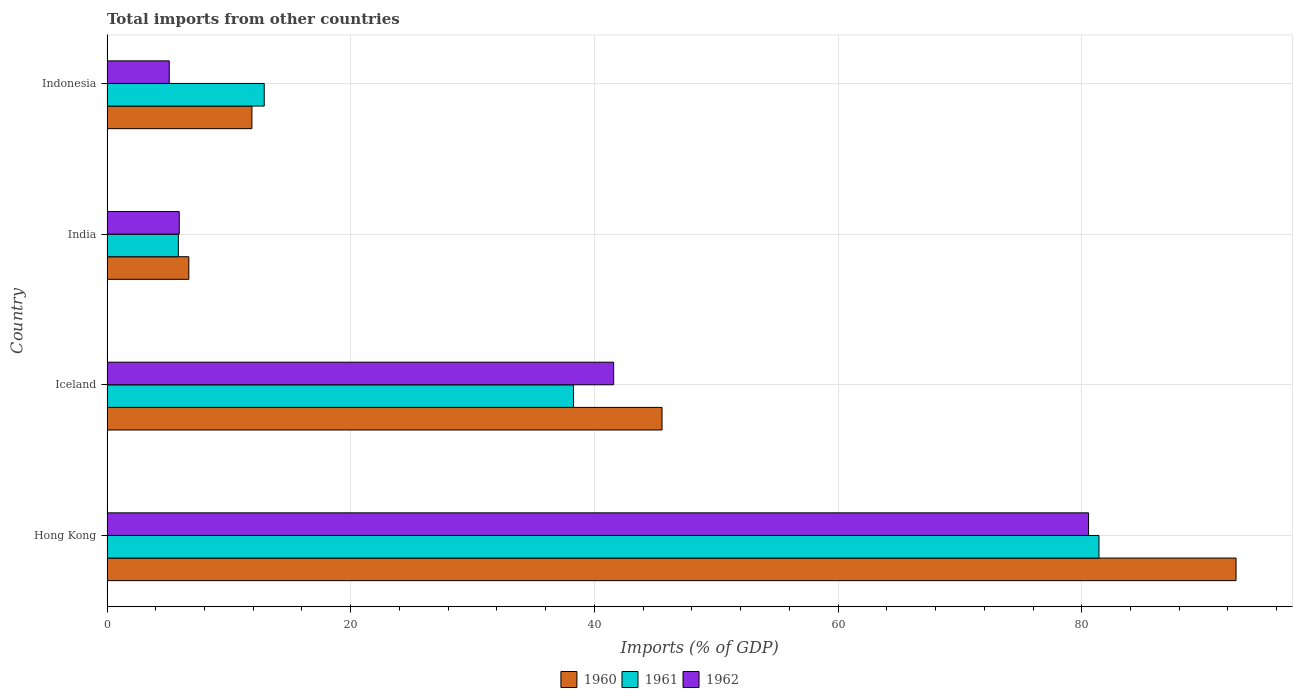How many different coloured bars are there?
Keep it short and to the point. 3. Are the number of bars per tick equal to the number of legend labels?
Your answer should be compact. Yes. Are the number of bars on each tick of the Y-axis equal?
Your response must be concise. Yes. How many bars are there on the 3rd tick from the top?
Ensure brevity in your answer.  3. In how many cases, is the number of bars for a given country not equal to the number of legend labels?
Your answer should be compact. 0. What is the total imports in 1962 in Iceland?
Your answer should be compact. 41.58. Across all countries, what is the maximum total imports in 1962?
Ensure brevity in your answer.  80.56. Across all countries, what is the minimum total imports in 1960?
Your response must be concise. 6.72. In which country was the total imports in 1962 maximum?
Your response must be concise. Hong Kong. What is the total total imports in 1962 in the graph?
Your answer should be very brief. 133.18. What is the difference between the total imports in 1962 in Iceland and that in India?
Give a very brief answer. 35.66. What is the difference between the total imports in 1961 in India and the total imports in 1960 in Indonesia?
Make the answer very short. -6.04. What is the average total imports in 1961 per country?
Give a very brief answer. 34.61. What is the difference between the total imports in 1962 and total imports in 1960 in Iceland?
Ensure brevity in your answer.  -3.97. In how many countries, is the total imports in 1961 greater than 60 %?
Make the answer very short. 1. What is the ratio of the total imports in 1962 in India to that in Indonesia?
Your answer should be compact. 1.16. What is the difference between the highest and the second highest total imports in 1961?
Provide a succinct answer. 43.13. What is the difference between the highest and the lowest total imports in 1962?
Provide a succinct answer. 75.45. In how many countries, is the total imports in 1960 greater than the average total imports in 1960 taken over all countries?
Offer a very short reply. 2. Is the sum of the total imports in 1962 in Hong Kong and Iceland greater than the maximum total imports in 1960 across all countries?
Your answer should be very brief. Yes. What does the 3rd bar from the top in India represents?
Your response must be concise. 1960. Is it the case that in every country, the sum of the total imports in 1962 and total imports in 1961 is greater than the total imports in 1960?
Your answer should be very brief. Yes. How many bars are there?
Offer a very short reply. 12. Are all the bars in the graph horizontal?
Your answer should be compact. Yes. Are the values on the major ticks of X-axis written in scientific E-notation?
Ensure brevity in your answer.  No. Where does the legend appear in the graph?
Provide a succinct answer. Bottom center. How many legend labels are there?
Your answer should be very brief. 3. What is the title of the graph?
Keep it short and to the point. Total imports from other countries. Does "1983" appear as one of the legend labels in the graph?
Offer a very short reply. No. What is the label or title of the X-axis?
Provide a short and direct response. Imports (% of GDP). What is the Imports (% of GDP) in 1960 in Hong Kong?
Provide a succinct answer. 92.66. What is the Imports (% of GDP) in 1961 in Hong Kong?
Your response must be concise. 81.41. What is the Imports (% of GDP) of 1962 in Hong Kong?
Give a very brief answer. 80.56. What is the Imports (% of GDP) in 1960 in Iceland?
Ensure brevity in your answer.  45.55. What is the Imports (% of GDP) in 1961 in Iceland?
Provide a succinct answer. 38.28. What is the Imports (% of GDP) of 1962 in Iceland?
Provide a succinct answer. 41.58. What is the Imports (% of GDP) in 1960 in India?
Provide a succinct answer. 6.72. What is the Imports (% of GDP) of 1961 in India?
Your response must be concise. 5.85. What is the Imports (% of GDP) in 1962 in India?
Your answer should be very brief. 5.93. What is the Imports (% of GDP) of 1960 in Indonesia?
Make the answer very short. 11.89. What is the Imports (% of GDP) of 1961 in Indonesia?
Give a very brief answer. 12.9. What is the Imports (% of GDP) of 1962 in Indonesia?
Offer a very short reply. 5.11. Across all countries, what is the maximum Imports (% of GDP) of 1960?
Your answer should be compact. 92.66. Across all countries, what is the maximum Imports (% of GDP) in 1961?
Provide a short and direct response. 81.41. Across all countries, what is the maximum Imports (% of GDP) in 1962?
Provide a succinct answer. 80.56. Across all countries, what is the minimum Imports (% of GDP) of 1960?
Give a very brief answer. 6.72. Across all countries, what is the minimum Imports (% of GDP) in 1961?
Keep it short and to the point. 5.85. Across all countries, what is the minimum Imports (% of GDP) in 1962?
Offer a very short reply. 5.11. What is the total Imports (% of GDP) of 1960 in the graph?
Ensure brevity in your answer.  156.83. What is the total Imports (% of GDP) of 1961 in the graph?
Give a very brief answer. 138.45. What is the total Imports (% of GDP) of 1962 in the graph?
Your answer should be compact. 133.18. What is the difference between the Imports (% of GDP) of 1960 in Hong Kong and that in Iceland?
Your answer should be very brief. 47.11. What is the difference between the Imports (% of GDP) in 1961 in Hong Kong and that in Iceland?
Provide a succinct answer. 43.13. What is the difference between the Imports (% of GDP) in 1962 in Hong Kong and that in Iceland?
Keep it short and to the point. 38.97. What is the difference between the Imports (% of GDP) of 1960 in Hong Kong and that in India?
Keep it short and to the point. 85.95. What is the difference between the Imports (% of GDP) in 1961 in Hong Kong and that in India?
Make the answer very short. 75.56. What is the difference between the Imports (% of GDP) of 1962 in Hong Kong and that in India?
Give a very brief answer. 74.63. What is the difference between the Imports (% of GDP) in 1960 in Hong Kong and that in Indonesia?
Your response must be concise. 80.77. What is the difference between the Imports (% of GDP) in 1961 in Hong Kong and that in Indonesia?
Your answer should be very brief. 68.51. What is the difference between the Imports (% of GDP) of 1962 in Hong Kong and that in Indonesia?
Ensure brevity in your answer.  75.45. What is the difference between the Imports (% of GDP) of 1960 in Iceland and that in India?
Keep it short and to the point. 38.84. What is the difference between the Imports (% of GDP) of 1961 in Iceland and that in India?
Offer a very short reply. 32.43. What is the difference between the Imports (% of GDP) of 1962 in Iceland and that in India?
Keep it short and to the point. 35.66. What is the difference between the Imports (% of GDP) in 1960 in Iceland and that in Indonesia?
Your answer should be very brief. 33.66. What is the difference between the Imports (% of GDP) in 1961 in Iceland and that in Indonesia?
Provide a short and direct response. 25.38. What is the difference between the Imports (% of GDP) of 1962 in Iceland and that in Indonesia?
Your response must be concise. 36.47. What is the difference between the Imports (% of GDP) in 1960 in India and that in Indonesia?
Keep it short and to the point. -5.18. What is the difference between the Imports (% of GDP) of 1961 in India and that in Indonesia?
Your answer should be very brief. -7.05. What is the difference between the Imports (% of GDP) in 1962 in India and that in Indonesia?
Your answer should be compact. 0.82. What is the difference between the Imports (% of GDP) of 1960 in Hong Kong and the Imports (% of GDP) of 1961 in Iceland?
Your response must be concise. 54.38. What is the difference between the Imports (% of GDP) of 1960 in Hong Kong and the Imports (% of GDP) of 1962 in Iceland?
Your answer should be very brief. 51.08. What is the difference between the Imports (% of GDP) of 1961 in Hong Kong and the Imports (% of GDP) of 1962 in Iceland?
Give a very brief answer. 39.83. What is the difference between the Imports (% of GDP) in 1960 in Hong Kong and the Imports (% of GDP) in 1961 in India?
Provide a short and direct response. 86.81. What is the difference between the Imports (% of GDP) in 1960 in Hong Kong and the Imports (% of GDP) in 1962 in India?
Make the answer very short. 86.74. What is the difference between the Imports (% of GDP) in 1961 in Hong Kong and the Imports (% of GDP) in 1962 in India?
Give a very brief answer. 75.49. What is the difference between the Imports (% of GDP) in 1960 in Hong Kong and the Imports (% of GDP) in 1961 in Indonesia?
Provide a succinct answer. 79.76. What is the difference between the Imports (% of GDP) of 1960 in Hong Kong and the Imports (% of GDP) of 1962 in Indonesia?
Offer a very short reply. 87.55. What is the difference between the Imports (% of GDP) of 1961 in Hong Kong and the Imports (% of GDP) of 1962 in Indonesia?
Make the answer very short. 76.3. What is the difference between the Imports (% of GDP) of 1960 in Iceland and the Imports (% of GDP) of 1961 in India?
Provide a short and direct response. 39.7. What is the difference between the Imports (% of GDP) of 1960 in Iceland and the Imports (% of GDP) of 1962 in India?
Offer a terse response. 39.63. What is the difference between the Imports (% of GDP) of 1961 in Iceland and the Imports (% of GDP) of 1962 in India?
Provide a succinct answer. 32.35. What is the difference between the Imports (% of GDP) in 1960 in Iceland and the Imports (% of GDP) in 1961 in Indonesia?
Your answer should be very brief. 32.65. What is the difference between the Imports (% of GDP) of 1960 in Iceland and the Imports (% of GDP) of 1962 in Indonesia?
Provide a short and direct response. 40.44. What is the difference between the Imports (% of GDP) in 1961 in Iceland and the Imports (% of GDP) in 1962 in Indonesia?
Offer a very short reply. 33.17. What is the difference between the Imports (% of GDP) in 1960 in India and the Imports (% of GDP) in 1961 in Indonesia?
Make the answer very short. -6.19. What is the difference between the Imports (% of GDP) in 1960 in India and the Imports (% of GDP) in 1962 in Indonesia?
Your answer should be very brief. 1.61. What is the difference between the Imports (% of GDP) of 1961 in India and the Imports (% of GDP) of 1962 in Indonesia?
Your response must be concise. 0.74. What is the average Imports (% of GDP) of 1960 per country?
Your answer should be compact. 39.21. What is the average Imports (% of GDP) in 1961 per country?
Offer a terse response. 34.61. What is the average Imports (% of GDP) of 1962 per country?
Offer a terse response. 33.3. What is the difference between the Imports (% of GDP) in 1960 and Imports (% of GDP) in 1961 in Hong Kong?
Give a very brief answer. 11.25. What is the difference between the Imports (% of GDP) in 1960 and Imports (% of GDP) in 1962 in Hong Kong?
Offer a very short reply. 12.1. What is the difference between the Imports (% of GDP) of 1961 and Imports (% of GDP) of 1962 in Hong Kong?
Offer a very short reply. 0.85. What is the difference between the Imports (% of GDP) in 1960 and Imports (% of GDP) in 1961 in Iceland?
Ensure brevity in your answer.  7.27. What is the difference between the Imports (% of GDP) of 1960 and Imports (% of GDP) of 1962 in Iceland?
Offer a terse response. 3.97. What is the difference between the Imports (% of GDP) of 1961 and Imports (% of GDP) of 1962 in Iceland?
Keep it short and to the point. -3.3. What is the difference between the Imports (% of GDP) of 1960 and Imports (% of GDP) of 1961 in India?
Give a very brief answer. 0.86. What is the difference between the Imports (% of GDP) of 1960 and Imports (% of GDP) of 1962 in India?
Your answer should be very brief. 0.79. What is the difference between the Imports (% of GDP) of 1961 and Imports (% of GDP) of 1962 in India?
Provide a short and direct response. -0.07. What is the difference between the Imports (% of GDP) in 1960 and Imports (% of GDP) in 1961 in Indonesia?
Ensure brevity in your answer.  -1.01. What is the difference between the Imports (% of GDP) of 1960 and Imports (% of GDP) of 1962 in Indonesia?
Your answer should be very brief. 6.78. What is the difference between the Imports (% of GDP) of 1961 and Imports (% of GDP) of 1962 in Indonesia?
Your answer should be compact. 7.79. What is the ratio of the Imports (% of GDP) in 1960 in Hong Kong to that in Iceland?
Offer a terse response. 2.03. What is the ratio of the Imports (% of GDP) of 1961 in Hong Kong to that in Iceland?
Provide a succinct answer. 2.13. What is the ratio of the Imports (% of GDP) of 1962 in Hong Kong to that in Iceland?
Make the answer very short. 1.94. What is the ratio of the Imports (% of GDP) in 1960 in Hong Kong to that in India?
Your answer should be very brief. 13.8. What is the ratio of the Imports (% of GDP) in 1961 in Hong Kong to that in India?
Your answer should be very brief. 13.91. What is the ratio of the Imports (% of GDP) in 1962 in Hong Kong to that in India?
Provide a succinct answer. 13.59. What is the ratio of the Imports (% of GDP) in 1960 in Hong Kong to that in Indonesia?
Offer a very short reply. 7.79. What is the ratio of the Imports (% of GDP) of 1961 in Hong Kong to that in Indonesia?
Offer a very short reply. 6.31. What is the ratio of the Imports (% of GDP) in 1962 in Hong Kong to that in Indonesia?
Your response must be concise. 15.76. What is the ratio of the Imports (% of GDP) of 1960 in Iceland to that in India?
Offer a terse response. 6.78. What is the ratio of the Imports (% of GDP) in 1961 in Iceland to that in India?
Your answer should be very brief. 6.54. What is the ratio of the Imports (% of GDP) of 1962 in Iceland to that in India?
Provide a succinct answer. 7.01. What is the ratio of the Imports (% of GDP) of 1960 in Iceland to that in Indonesia?
Keep it short and to the point. 3.83. What is the ratio of the Imports (% of GDP) of 1961 in Iceland to that in Indonesia?
Ensure brevity in your answer.  2.97. What is the ratio of the Imports (% of GDP) in 1962 in Iceland to that in Indonesia?
Offer a very short reply. 8.14. What is the ratio of the Imports (% of GDP) of 1960 in India to that in Indonesia?
Your answer should be compact. 0.56. What is the ratio of the Imports (% of GDP) in 1961 in India to that in Indonesia?
Offer a very short reply. 0.45. What is the ratio of the Imports (% of GDP) of 1962 in India to that in Indonesia?
Provide a short and direct response. 1.16. What is the difference between the highest and the second highest Imports (% of GDP) of 1960?
Keep it short and to the point. 47.11. What is the difference between the highest and the second highest Imports (% of GDP) in 1961?
Provide a succinct answer. 43.13. What is the difference between the highest and the second highest Imports (% of GDP) of 1962?
Your answer should be compact. 38.97. What is the difference between the highest and the lowest Imports (% of GDP) in 1960?
Ensure brevity in your answer.  85.95. What is the difference between the highest and the lowest Imports (% of GDP) in 1961?
Your answer should be very brief. 75.56. What is the difference between the highest and the lowest Imports (% of GDP) in 1962?
Ensure brevity in your answer.  75.45. 